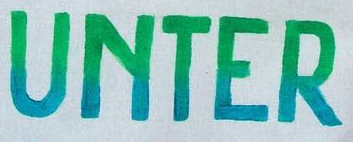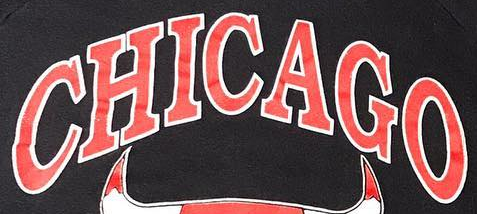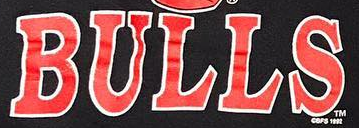What text is displayed in these images sequentially, separated by a semicolon? UNTER; CHICAGO; BULLS 